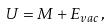Convert formula to latex. <formula><loc_0><loc_0><loc_500><loc_500>U = M + E _ { v a c } \, ,</formula> 